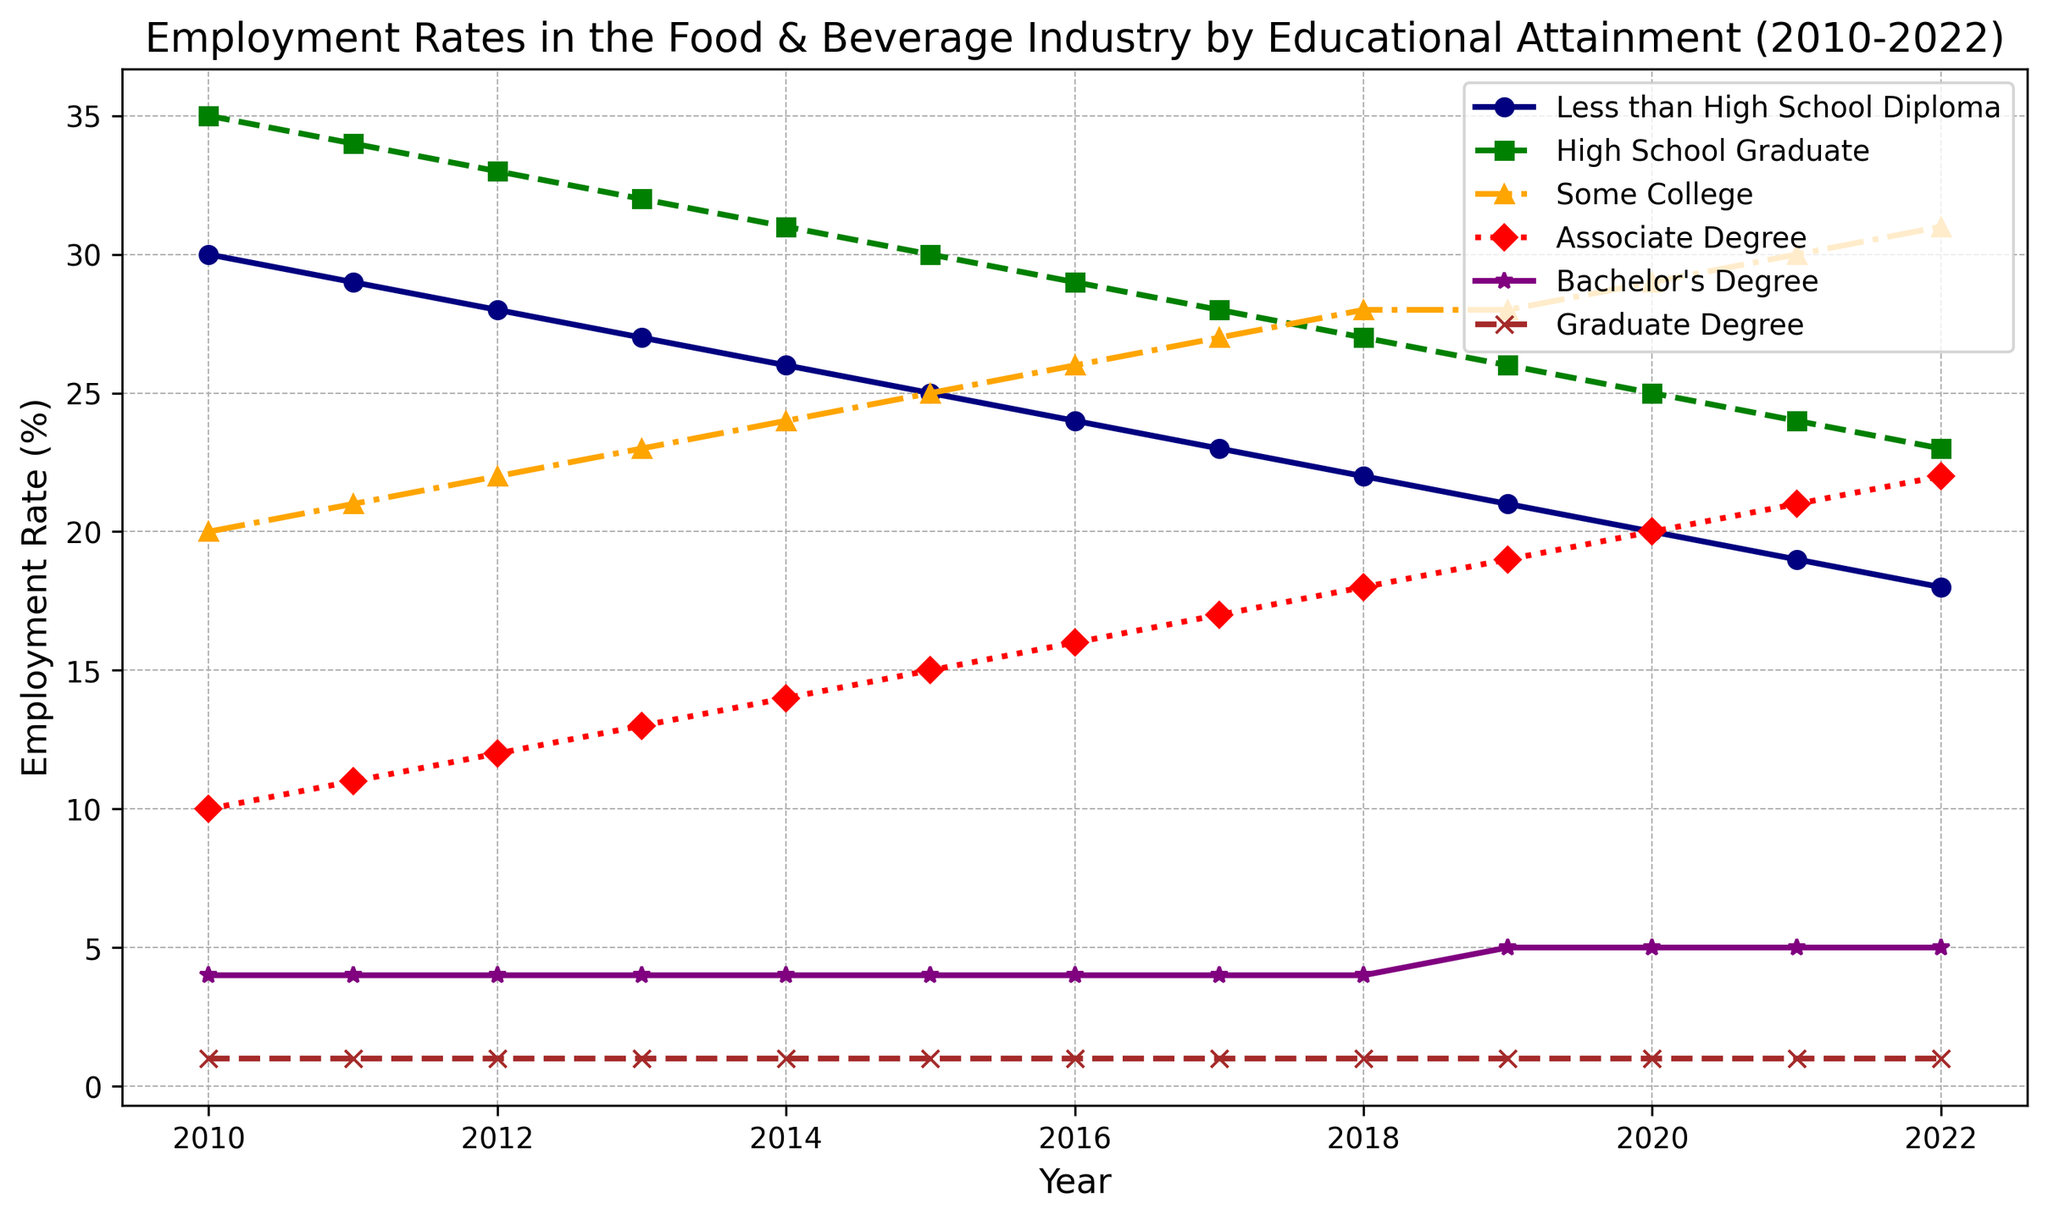Which educational attainment level had the highest employment rate in 2010? Look at the year 2010 and find the line that reaches the highest point on the y-axis. The line for 'High School Graduate' at 35% is the highest.
Answer: High School Graduate How did the employment rate for Associate Degree change from 2010 to 2022? Find the value for 'Associate Degree' in 2010 (10%) and in 2022 (22%). Calculate the difference: 22% - 10% = 12%.
Answer: Increased by 12% In which year did Less than High School Diploma and Some College have an equal employment rate? Identify where the lines for 'Less than High School Diploma' and 'Some College' intersect. They intersect in 2019, both at 21% and 28%.
Answer: Never intersected exactly, but got closest in 2019 Which line showed the most consistent trend over the years? Find the line with the least fluctuation in its gradient. The line for 'Graduate Degree' (always at 1%) is the most consistent.
Answer: Graduate Degree Between 2015 and 2022, which educational attainment levels saw an increase in employment rates? Compare the values for 2015 and 2022 for each level: 
- Less than High School Diploma: 25% to 18%, decrease
- High School Graduate: 30% to 23%, decrease
- Some College: 25% to 31%, increase
- Associate Degree: 15% to 22%, increase
- Bachelor’s Degree: 4% to 5%, increase
- Graduate Degree: 1%, no change 
Three levels increased: Some College, Associate Degree, and Bachelor’s Degree.
Answer: Some College, Associate Degree, Bachelor's Degree What is the overall trend in employment rates for people with Less than High School Diploma from 2010 to 2022? Identify the changes in values for 'Less than High School Diploma' from 2010 (30%) to 2022 (18%). The trend is consistently downward.
Answer: Decreasing How does the employment rate for people with a Graduate Degree in 2022 compare to those with a High School Diploma in the same year? Look at the year 2022 for 'Graduate Degree' (1%) and 'High School Diploma' (23%). 'High School Diploma' has a much higher rate.
Answer: High School Diploma is higher Which year had the smallest gap between the employment rates of Some College and Associate Degree? Calculate the differences for each year:
- 2010: 20% - 10% = 10%
- 2011: 21% - 11% = 10%
- 2012: 22% - 12% = 10%
- 2013: 23% - 13% = 10%
- 2014: 24% - 14% = 10%
- 2015: 25% - 15% = 10%
- 2016: 26% - 16% = 10%
- 2017: 27% - 17% = 10%
- 2018: 28% - 18% = 10%
- 2019: 28% - 19% = 9%
- 2020: 29% - 20% = 9%
- 2021: 30% - 21% = 9%
- 2022: 31% - 22% = 9%
The gaps are smallest in 2019, 2020, 2021, and 2022, all at 9%.
Answer: 2019, 2020, 2021, 2022 What is the employment rate difference in 2022 between Bachelor's Degree and High School Graduate? Find the values for 2022: Bachelor's (5%) and High School Graduate (23%). Calculate the difference: 23% - 5% = 18%.
Answer: 18% 